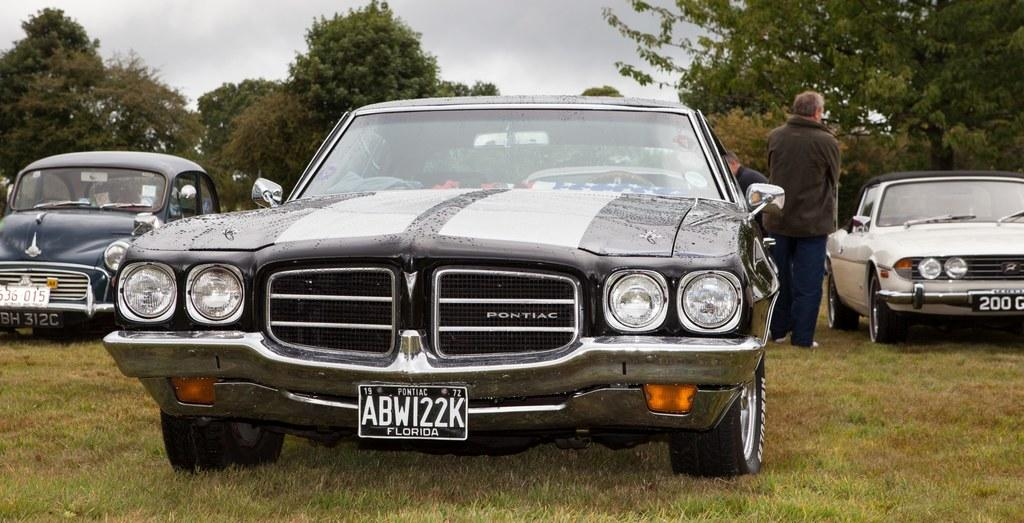What is the main subject of the image? The main subject of the image is a car. Can you describe the appearance of the car? The car is black and white in color. Where is the car located in the image? The car is on the ground. How many other cars can be seen in the image? There are 2 other cars in the background of the image. What else is visible in the background of the image? There are people, trees, and the sky visible in the background of the image. Reasoning: Let' Let's think step by step in order to produce the conversation. We start by identifying the main subject of the image, which is the car. Then, we describe the appearance of the car, including its color. Next, we specify the location of the car in the image, which is on the ground. We then expand the conversation to include other cars and elements visible in the background, such as people, trees, and the sky. Each question is designed to elicit a specific detail about the image that is known from the provided facts. Absurd Question/Answer: How many times has the car been folded in the image? The car cannot be folded, so it has not been folded any number of times in the image. 